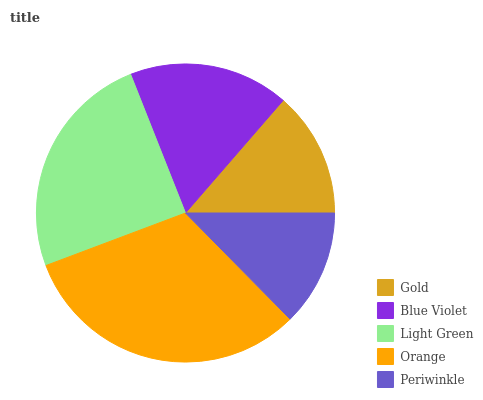Is Periwinkle the minimum?
Answer yes or no. Yes. Is Orange the maximum?
Answer yes or no. Yes. Is Blue Violet the minimum?
Answer yes or no. No. Is Blue Violet the maximum?
Answer yes or no. No. Is Blue Violet greater than Gold?
Answer yes or no. Yes. Is Gold less than Blue Violet?
Answer yes or no. Yes. Is Gold greater than Blue Violet?
Answer yes or no. No. Is Blue Violet less than Gold?
Answer yes or no. No. Is Blue Violet the high median?
Answer yes or no. Yes. Is Blue Violet the low median?
Answer yes or no. Yes. Is Orange the high median?
Answer yes or no. No. Is Periwinkle the low median?
Answer yes or no. No. 